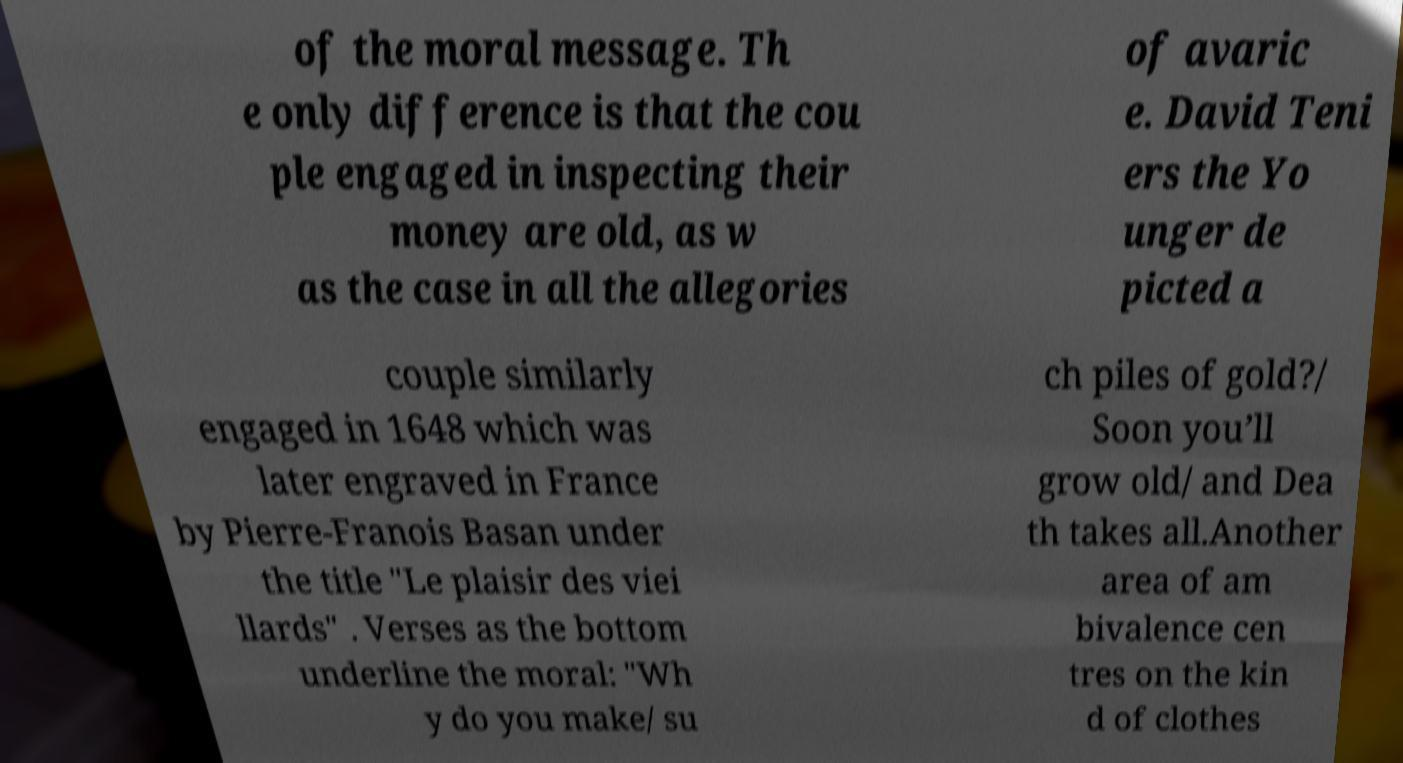Please read and relay the text visible in this image. What does it say? of the moral message. Th e only difference is that the cou ple engaged in inspecting their money are old, as w as the case in all the allegories of avaric e. David Teni ers the Yo unger de picted a couple similarly engaged in 1648 which was later engraved in France by Pierre-Franois Basan under the title "Le plaisir des viei llards" . Verses as the bottom underline the moral: "Wh y do you make/ su ch piles of gold?/ Soon you’ll grow old/ and Dea th takes all.Another area of am bivalence cen tres on the kin d of clothes 